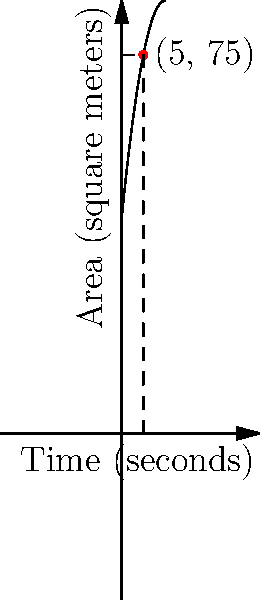In a magical Quidditch match, the pitch is expanding over time due to an enchantment. The area $A$ (in square meters) of the pitch at time $t$ (in seconds) is given by the function $A(t) = 50 + 10t - 0.5t^2$. At $t = 5$ seconds, what is the instantaneous rate of change of the pitch's area? To find the instantaneous rate of change at $t = 5$ seconds, we need to calculate the derivative of the function $A(t)$ and evaluate it at $t = 5$.

Step 1: Find the derivative of $A(t)$.
$A(t) = 50 + 10t - 0.5t^2$
$A'(t) = 10 - t$

Step 2: Evaluate $A'(t)$ at $t = 5$.
$A'(5) = 10 - 5 = 5$

Therefore, at $t = 5$ seconds, the instantaneous rate of change of the pitch's area is 5 square meters per second.

Note: The positive value indicates that the area is still increasing at this point, but the rate of increase is slowing down due to the negative coefficient of $t^2$ in the original function.
Answer: 5 m²/s 